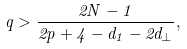<formula> <loc_0><loc_0><loc_500><loc_500>q > \frac { 2 N - 1 } { 2 p + 4 - d _ { 1 } - 2 d _ { \perp } } ,</formula> 